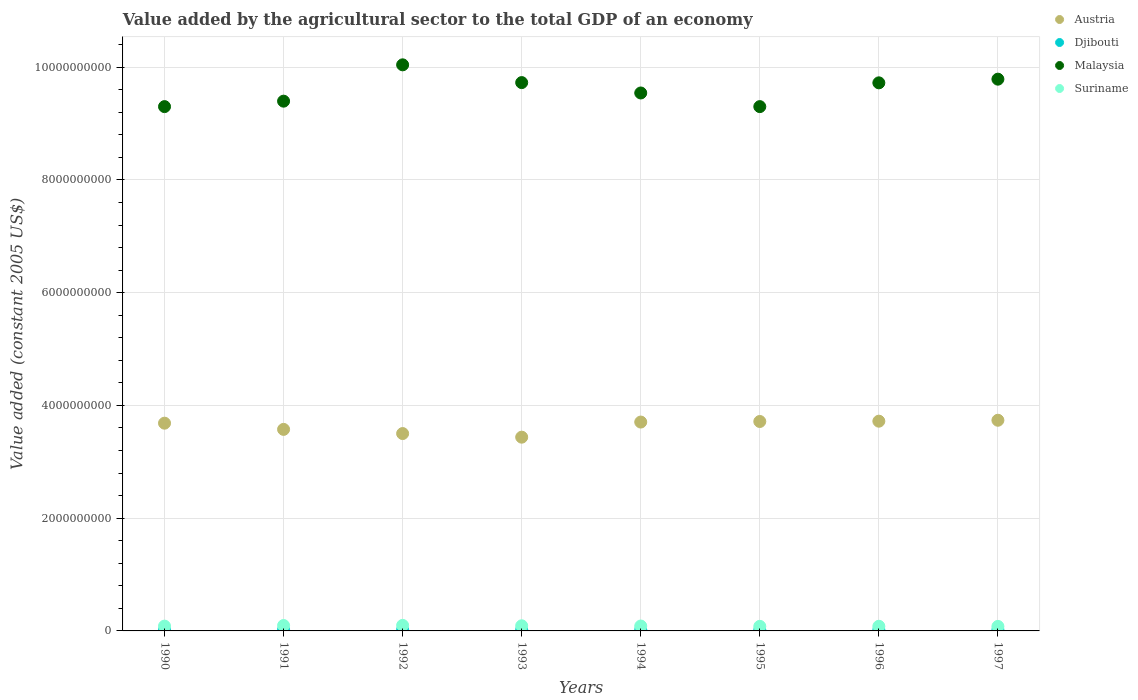What is the value added by the agricultural sector in Austria in 1997?
Provide a short and direct response. 3.74e+09. Across all years, what is the maximum value added by the agricultural sector in Suriname?
Keep it short and to the point. 9.80e+07. Across all years, what is the minimum value added by the agricultural sector in Suriname?
Your answer should be compact. 8.00e+07. What is the total value added by the agricultural sector in Djibouti in the graph?
Your response must be concise. 1.55e+08. What is the difference between the value added by the agricultural sector in Suriname in 1990 and that in 1993?
Provide a succinct answer. -5.70e+06. What is the difference between the value added by the agricultural sector in Austria in 1995 and the value added by the agricultural sector in Suriname in 1996?
Your answer should be very brief. 3.63e+09. What is the average value added by the agricultural sector in Malaysia per year?
Offer a very short reply. 9.60e+09. In the year 1991, what is the difference between the value added by the agricultural sector in Austria and value added by the agricultural sector in Suriname?
Your response must be concise. 3.48e+09. What is the ratio of the value added by the agricultural sector in Suriname in 1993 to that in 1996?
Ensure brevity in your answer.  1.1. Is the difference between the value added by the agricultural sector in Austria in 1994 and 1995 greater than the difference between the value added by the agricultural sector in Suriname in 1994 and 1995?
Your answer should be very brief. No. What is the difference between the highest and the second highest value added by the agricultural sector in Djibouti?
Keep it short and to the point. 2.11e+05. What is the difference between the highest and the lowest value added by the agricultural sector in Austria?
Ensure brevity in your answer.  3.00e+08. Is the value added by the agricultural sector in Suriname strictly greater than the value added by the agricultural sector in Djibouti over the years?
Provide a succinct answer. Yes. Is the value added by the agricultural sector in Malaysia strictly less than the value added by the agricultural sector in Djibouti over the years?
Your response must be concise. No. How many dotlines are there?
Your answer should be compact. 4. How many years are there in the graph?
Give a very brief answer. 8. Does the graph contain grids?
Provide a short and direct response. Yes. Where does the legend appear in the graph?
Your answer should be compact. Top right. What is the title of the graph?
Give a very brief answer. Value added by the agricultural sector to the total GDP of an economy. Does "Mauritania" appear as one of the legend labels in the graph?
Make the answer very short. No. What is the label or title of the X-axis?
Your answer should be very brief. Years. What is the label or title of the Y-axis?
Make the answer very short. Value added (constant 2005 US$). What is the Value added (constant 2005 US$) in Austria in 1990?
Provide a short and direct response. 3.69e+09. What is the Value added (constant 2005 US$) of Djibouti in 1990?
Your response must be concise. 1.96e+07. What is the Value added (constant 2005 US$) in Malaysia in 1990?
Provide a succinct answer. 9.30e+09. What is the Value added (constant 2005 US$) of Suriname in 1990?
Your answer should be very brief. 8.52e+07. What is the Value added (constant 2005 US$) in Austria in 1991?
Offer a very short reply. 3.58e+09. What is the Value added (constant 2005 US$) of Djibouti in 1991?
Give a very brief answer. 1.95e+07. What is the Value added (constant 2005 US$) in Malaysia in 1991?
Provide a short and direct response. 9.40e+09. What is the Value added (constant 2005 US$) in Suriname in 1991?
Offer a terse response. 9.58e+07. What is the Value added (constant 2005 US$) of Austria in 1992?
Give a very brief answer. 3.50e+09. What is the Value added (constant 2005 US$) of Djibouti in 1992?
Ensure brevity in your answer.  2.03e+07. What is the Value added (constant 2005 US$) in Malaysia in 1992?
Ensure brevity in your answer.  1.00e+1. What is the Value added (constant 2005 US$) of Suriname in 1992?
Your answer should be very brief. 9.80e+07. What is the Value added (constant 2005 US$) in Austria in 1993?
Make the answer very short. 3.44e+09. What is the Value added (constant 2005 US$) of Djibouti in 1993?
Provide a short and direct response. 2.05e+07. What is the Value added (constant 2005 US$) in Malaysia in 1993?
Your answer should be very brief. 9.73e+09. What is the Value added (constant 2005 US$) of Suriname in 1993?
Provide a succinct answer. 9.09e+07. What is the Value added (constant 2005 US$) in Austria in 1994?
Provide a short and direct response. 3.71e+09. What is the Value added (constant 2005 US$) in Djibouti in 1994?
Ensure brevity in your answer.  2.07e+07. What is the Value added (constant 2005 US$) in Malaysia in 1994?
Keep it short and to the point. 9.54e+09. What is the Value added (constant 2005 US$) in Suriname in 1994?
Offer a very short reply. 8.69e+07. What is the Value added (constant 2005 US$) of Austria in 1995?
Offer a very short reply. 3.72e+09. What is the Value added (constant 2005 US$) of Djibouti in 1995?
Your answer should be very brief. 1.77e+07. What is the Value added (constant 2005 US$) in Malaysia in 1995?
Your answer should be compact. 9.30e+09. What is the Value added (constant 2005 US$) of Suriname in 1995?
Keep it short and to the point. 8.12e+07. What is the Value added (constant 2005 US$) of Austria in 1996?
Your answer should be compact. 3.72e+09. What is the Value added (constant 2005 US$) of Djibouti in 1996?
Your answer should be very brief. 1.83e+07. What is the Value added (constant 2005 US$) of Malaysia in 1996?
Offer a very short reply. 9.72e+09. What is the Value added (constant 2005 US$) in Suriname in 1996?
Keep it short and to the point. 8.24e+07. What is the Value added (constant 2005 US$) of Austria in 1997?
Give a very brief answer. 3.74e+09. What is the Value added (constant 2005 US$) in Djibouti in 1997?
Provide a short and direct response. 1.83e+07. What is the Value added (constant 2005 US$) of Malaysia in 1997?
Provide a short and direct response. 9.79e+09. What is the Value added (constant 2005 US$) of Suriname in 1997?
Keep it short and to the point. 8.00e+07. Across all years, what is the maximum Value added (constant 2005 US$) in Austria?
Your response must be concise. 3.74e+09. Across all years, what is the maximum Value added (constant 2005 US$) in Djibouti?
Make the answer very short. 2.07e+07. Across all years, what is the maximum Value added (constant 2005 US$) of Malaysia?
Ensure brevity in your answer.  1.00e+1. Across all years, what is the maximum Value added (constant 2005 US$) in Suriname?
Provide a short and direct response. 9.80e+07. Across all years, what is the minimum Value added (constant 2005 US$) of Austria?
Your response must be concise. 3.44e+09. Across all years, what is the minimum Value added (constant 2005 US$) in Djibouti?
Provide a succinct answer. 1.77e+07. Across all years, what is the minimum Value added (constant 2005 US$) in Malaysia?
Your response must be concise. 9.30e+09. Across all years, what is the minimum Value added (constant 2005 US$) of Suriname?
Your response must be concise. 8.00e+07. What is the total Value added (constant 2005 US$) of Austria in the graph?
Make the answer very short. 2.91e+1. What is the total Value added (constant 2005 US$) of Djibouti in the graph?
Offer a terse response. 1.55e+08. What is the total Value added (constant 2005 US$) in Malaysia in the graph?
Offer a very short reply. 7.68e+1. What is the total Value added (constant 2005 US$) in Suriname in the graph?
Give a very brief answer. 7.00e+08. What is the difference between the Value added (constant 2005 US$) in Austria in 1990 and that in 1991?
Provide a short and direct response. 1.10e+08. What is the difference between the Value added (constant 2005 US$) of Djibouti in 1990 and that in 1991?
Your response must be concise. 3.64e+04. What is the difference between the Value added (constant 2005 US$) in Malaysia in 1990 and that in 1991?
Your answer should be very brief. -9.67e+07. What is the difference between the Value added (constant 2005 US$) in Suriname in 1990 and that in 1991?
Give a very brief answer. -1.06e+07. What is the difference between the Value added (constant 2005 US$) of Austria in 1990 and that in 1992?
Keep it short and to the point. 1.84e+08. What is the difference between the Value added (constant 2005 US$) of Djibouti in 1990 and that in 1992?
Ensure brevity in your answer.  -7.27e+05. What is the difference between the Value added (constant 2005 US$) of Malaysia in 1990 and that in 1992?
Give a very brief answer. -7.41e+08. What is the difference between the Value added (constant 2005 US$) of Suriname in 1990 and that in 1992?
Provide a succinct answer. -1.28e+07. What is the difference between the Value added (constant 2005 US$) of Austria in 1990 and that in 1993?
Your response must be concise. 2.48e+08. What is the difference between the Value added (constant 2005 US$) of Djibouti in 1990 and that in 1993?
Offer a very short reply. -9.41e+05. What is the difference between the Value added (constant 2005 US$) in Malaysia in 1990 and that in 1993?
Give a very brief answer. -4.26e+08. What is the difference between the Value added (constant 2005 US$) in Suriname in 1990 and that in 1993?
Keep it short and to the point. -5.70e+06. What is the difference between the Value added (constant 2005 US$) in Austria in 1990 and that in 1994?
Keep it short and to the point. -1.99e+07. What is the difference between the Value added (constant 2005 US$) of Djibouti in 1990 and that in 1994?
Offer a terse response. -1.15e+06. What is the difference between the Value added (constant 2005 US$) in Malaysia in 1990 and that in 1994?
Make the answer very short. -2.42e+08. What is the difference between the Value added (constant 2005 US$) in Suriname in 1990 and that in 1994?
Provide a short and direct response. -1.63e+06. What is the difference between the Value added (constant 2005 US$) in Austria in 1990 and that in 1995?
Provide a short and direct response. -2.99e+07. What is the difference between the Value added (constant 2005 US$) of Djibouti in 1990 and that in 1995?
Give a very brief answer. 1.84e+06. What is the difference between the Value added (constant 2005 US$) of Suriname in 1990 and that in 1995?
Your answer should be compact. 4.07e+06. What is the difference between the Value added (constant 2005 US$) of Austria in 1990 and that in 1996?
Provide a succinct answer. -3.54e+07. What is the difference between the Value added (constant 2005 US$) of Djibouti in 1990 and that in 1996?
Ensure brevity in your answer.  1.24e+06. What is the difference between the Value added (constant 2005 US$) of Malaysia in 1990 and that in 1996?
Provide a succinct answer. -4.22e+08. What is the difference between the Value added (constant 2005 US$) of Suriname in 1990 and that in 1996?
Your answer should be compact. 2.82e+06. What is the difference between the Value added (constant 2005 US$) of Austria in 1990 and that in 1997?
Provide a short and direct response. -5.19e+07. What is the difference between the Value added (constant 2005 US$) in Djibouti in 1990 and that in 1997?
Give a very brief answer. 1.31e+06. What is the difference between the Value added (constant 2005 US$) in Malaysia in 1990 and that in 1997?
Your answer should be very brief. -4.87e+08. What is the difference between the Value added (constant 2005 US$) in Suriname in 1990 and that in 1997?
Your answer should be compact. 5.27e+06. What is the difference between the Value added (constant 2005 US$) in Austria in 1991 and that in 1992?
Provide a succinct answer. 7.42e+07. What is the difference between the Value added (constant 2005 US$) of Djibouti in 1991 and that in 1992?
Make the answer very short. -7.63e+05. What is the difference between the Value added (constant 2005 US$) in Malaysia in 1991 and that in 1992?
Give a very brief answer. -6.45e+08. What is the difference between the Value added (constant 2005 US$) in Suriname in 1991 and that in 1992?
Provide a short and direct response. -2.17e+06. What is the difference between the Value added (constant 2005 US$) of Austria in 1991 and that in 1993?
Your answer should be compact. 1.38e+08. What is the difference between the Value added (constant 2005 US$) in Djibouti in 1991 and that in 1993?
Ensure brevity in your answer.  -9.78e+05. What is the difference between the Value added (constant 2005 US$) in Malaysia in 1991 and that in 1993?
Offer a terse response. -3.29e+08. What is the difference between the Value added (constant 2005 US$) in Suriname in 1991 and that in 1993?
Ensure brevity in your answer.  4.89e+06. What is the difference between the Value added (constant 2005 US$) of Austria in 1991 and that in 1994?
Keep it short and to the point. -1.30e+08. What is the difference between the Value added (constant 2005 US$) of Djibouti in 1991 and that in 1994?
Your response must be concise. -1.19e+06. What is the difference between the Value added (constant 2005 US$) in Malaysia in 1991 and that in 1994?
Provide a succinct answer. -1.45e+08. What is the difference between the Value added (constant 2005 US$) in Suriname in 1991 and that in 1994?
Make the answer very short. 8.96e+06. What is the difference between the Value added (constant 2005 US$) of Austria in 1991 and that in 1995?
Keep it short and to the point. -1.40e+08. What is the difference between the Value added (constant 2005 US$) in Djibouti in 1991 and that in 1995?
Your answer should be very brief. 1.80e+06. What is the difference between the Value added (constant 2005 US$) of Malaysia in 1991 and that in 1995?
Provide a succinct answer. 9.67e+07. What is the difference between the Value added (constant 2005 US$) of Suriname in 1991 and that in 1995?
Make the answer very short. 1.47e+07. What is the difference between the Value added (constant 2005 US$) in Austria in 1991 and that in 1996?
Your answer should be compact. -1.45e+08. What is the difference between the Value added (constant 2005 US$) of Djibouti in 1991 and that in 1996?
Ensure brevity in your answer.  1.21e+06. What is the difference between the Value added (constant 2005 US$) of Malaysia in 1991 and that in 1996?
Your response must be concise. -3.25e+08. What is the difference between the Value added (constant 2005 US$) in Suriname in 1991 and that in 1996?
Offer a terse response. 1.34e+07. What is the difference between the Value added (constant 2005 US$) of Austria in 1991 and that in 1997?
Make the answer very short. -1.62e+08. What is the difference between the Value added (constant 2005 US$) of Djibouti in 1991 and that in 1997?
Keep it short and to the point. 1.27e+06. What is the difference between the Value added (constant 2005 US$) in Malaysia in 1991 and that in 1997?
Give a very brief answer. -3.90e+08. What is the difference between the Value added (constant 2005 US$) in Suriname in 1991 and that in 1997?
Your response must be concise. 1.59e+07. What is the difference between the Value added (constant 2005 US$) in Austria in 1992 and that in 1993?
Your response must be concise. 6.41e+07. What is the difference between the Value added (constant 2005 US$) in Djibouti in 1992 and that in 1993?
Your answer should be very brief. -2.15e+05. What is the difference between the Value added (constant 2005 US$) of Malaysia in 1992 and that in 1993?
Your answer should be compact. 3.15e+08. What is the difference between the Value added (constant 2005 US$) of Suriname in 1992 and that in 1993?
Your answer should be very brief. 7.06e+06. What is the difference between the Value added (constant 2005 US$) of Austria in 1992 and that in 1994?
Your answer should be compact. -2.04e+08. What is the difference between the Value added (constant 2005 US$) in Djibouti in 1992 and that in 1994?
Your answer should be very brief. -4.26e+05. What is the difference between the Value added (constant 2005 US$) of Malaysia in 1992 and that in 1994?
Provide a short and direct response. 4.99e+08. What is the difference between the Value added (constant 2005 US$) of Suriname in 1992 and that in 1994?
Your response must be concise. 1.11e+07. What is the difference between the Value added (constant 2005 US$) of Austria in 1992 and that in 1995?
Offer a terse response. -2.14e+08. What is the difference between the Value added (constant 2005 US$) in Djibouti in 1992 and that in 1995?
Provide a short and direct response. 2.56e+06. What is the difference between the Value added (constant 2005 US$) of Malaysia in 1992 and that in 1995?
Provide a short and direct response. 7.41e+08. What is the difference between the Value added (constant 2005 US$) of Suriname in 1992 and that in 1995?
Your answer should be compact. 1.68e+07. What is the difference between the Value added (constant 2005 US$) in Austria in 1992 and that in 1996?
Your answer should be compact. -2.20e+08. What is the difference between the Value added (constant 2005 US$) in Djibouti in 1992 and that in 1996?
Your response must be concise. 1.97e+06. What is the difference between the Value added (constant 2005 US$) of Malaysia in 1992 and that in 1996?
Your answer should be compact. 3.20e+08. What is the difference between the Value added (constant 2005 US$) of Suriname in 1992 and that in 1996?
Keep it short and to the point. 1.56e+07. What is the difference between the Value added (constant 2005 US$) in Austria in 1992 and that in 1997?
Keep it short and to the point. -2.36e+08. What is the difference between the Value added (constant 2005 US$) of Djibouti in 1992 and that in 1997?
Your answer should be very brief. 2.03e+06. What is the difference between the Value added (constant 2005 US$) in Malaysia in 1992 and that in 1997?
Keep it short and to the point. 2.54e+08. What is the difference between the Value added (constant 2005 US$) in Suriname in 1992 and that in 1997?
Provide a short and direct response. 1.80e+07. What is the difference between the Value added (constant 2005 US$) in Austria in 1993 and that in 1994?
Ensure brevity in your answer.  -2.68e+08. What is the difference between the Value added (constant 2005 US$) in Djibouti in 1993 and that in 1994?
Provide a succinct answer. -2.11e+05. What is the difference between the Value added (constant 2005 US$) of Malaysia in 1993 and that in 1994?
Make the answer very short. 1.84e+08. What is the difference between the Value added (constant 2005 US$) in Suriname in 1993 and that in 1994?
Provide a succinct answer. 4.07e+06. What is the difference between the Value added (constant 2005 US$) of Austria in 1993 and that in 1995?
Your answer should be compact. -2.78e+08. What is the difference between the Value added (constant 2005 US$) in Djibouti in 1993 and that in 1995?
Ensure brevity in your answer.  2.78e+06. What is the difference between the Value added (constant 2005 US$) of Malaysia in 1993 and that in 1995?
Provide a succinct answer. 4.26e+08. What is the difference between the Value added (constant 2005 US$) in Suriname in 1993 and that in 1995?
Provide a succinct answer. 9.77e+06. What is the difference between the Value added (constant 2005 US$) in Austria in 1993 and that in 1996?
Your answer should be very brief. -2.84e+08. What is the difference between the Value added (constant 2005 US$) of Djibouti in 1993 and that in 1996?
Your response must be concise. 2.18e+06. What is the difference between the Value added (constant 2005 US$) in Malaysia in 1993 and that in 1996?
Keep it short and to the point. 4.35e+06. What is the difference between the Value added (constant 2005 US$) of Suriname in 1993 and that in 1996?
Make the answer very short. 8.52e+06. What is the difference between the Value added (constant 2005 US$) of Austria in 1993 and that in 1997?
Make the answer very short. -3.00e+08. What is the difference between the Value added (constant 2005 US$) in Djibouti in 1993 and that in 1997?
Make the answer very short. 2.25e+06. What is the difference between the Value added (constant 2005 US$) in Malaysia in 1993 and that in 1997?
Your response must be concise. -6.09e+07. What is the difference between the Value added (constant 2005 US$) of Suriname in 1993 and that in 1997?
Your answer should be compact. 1.10e+07. What is the difference between the Value added (constant 2005 US$) of Austria in 1994 and that in 1995?
Your response must be concise. -1.01e+07. What is the difference between the Value added (constant 2005 US$) in Djibouti in 1994 and that in 1995?
Make the answer very short. 2.99e+06. What is the difference between the Value added (constant 2005 US$) in Malaysia in 1994 and that in 1995?
Offer a terse response. 2.42e+08. What is the difference between the Value added (constant 2005 US$) of Suriname in 1994 and that in 1995?
Your answer should be very brief. 5.70e+06. What is the difference between the Value added (constant 2005 US$) in Austria in 1994 and that in 1996?
Your answer should be very brief. -1.56e+07. What is the difference between the Value added (constant 2005 US$) of Djibouti in 1994 and that in 1996?
Your answer should be compact. 2.40e+06. What is the difference between the Value added (constant 2005 US$) of Malaysia in 1994 and that in 1996?
Offer a very short reply. -1.80e+08. What is the difference between the Value added (constant 2005 US$) of Suriname in 1994 and that in 1996?
Your answer should be compact. 4.45e+06. What is the difference between the Value added (constant 2005 US$) in Austria in 1994 and that in 1997?
Offer a very short reply. -3.21e+07. What is the difference between the Value added (constant 2005 US$) in Djibouti in 1994 and that in 1997?
Give a very brief answer. 2.46e+06. What is the difference between the Value added (constant 2005 US$) in Malaysia in 1994 and that in 1997?
Your answer should be very brief. -2.45e+08. What is the difference between the Value added (constant 2005 US$) of Suriname in 1994 and that in 1997?
Provide a short and direct response. 6.90e+06. What is the difference between the Value added (constant 2005 US$) of Austria in 1995 and that in 1996?
Make the answer very short. -5.47e+06. What is the difference between the Value added (constant 2005 US$) of Djibouti in 1995 and that in 1996?
Provide a short and direct response. -5.95e+05. What is the difference between the Value added (constant 2005 US$) of Malaysia in 1995 and that in 1996?
Offer a terse response. -4.22e+08. What is the difference between the Value added (constant 2005 US$) of Suriname in 1995 and that in 1996?
Provide a short and direct response. -1.25e+06. What is the difference between the Value added (constant 2005 US$) of Austria in 1995 and that in 1997?
Provide a short and direct response. -2.20e+07. What is the difference between the Value added (constant 2005 US$) in Djibouti in 1995 and that in 1997?
Your response must be concise. -5.31e+05. What is the difference between the Value added (constant 2005 US$) of Malaysia in 1995 and that in 1997?
Make the answer very short. -4.87e+08. What is the difference between the Value added (constant 2005 US$) in Suriname in 1995 and that in 1997?
Give a very brief answer. 1.19e+06. What is the difference between the Value added (constant 2005 US$) in Austria in 1996 and that in 1997?
Offer a very short reply. -1.65e+07. What is the difference between the Value added (constant 2005 US$) in Djibouti in 1996 and that in 1997?
Make the answer very short. 6.39e+04. What is the difference between the Value added (constant 2005 US$) of Malaysia in 1996 and that in 1997?
Offer a terse response. -6.52e+07. What is the difference between the Value added (constant 2005 US$) in Suriname in 1996 and that in 1997?
Give a very brief answer. 2.44e+06. What is the difference between the Value added (constant 2005 US$) of Austria in 1990 and the Value added (constant 2005 US$) of Djibouti in 1991?
Your answer should be compact. 3.67e+09. What is the difference between the Value added (constant 2005 US$) in Austria in 1990 and the Value added (constant 2005 US$) in Malaysia in 1991?
Your answer should be compact. -5.71e+09. What is the difference between the Value added (constant 2005 US$) of Austria in 1990 and the Value added (constant 2005 US$) of Suriname in 1991?
Provide a succinct answer. 3.59e+09. What is the difference between the Value added (constant 2005 US$) in Djibouti in 1990 and the Value added (constant 2005 US$) in Malaysia in 1991?
Provide a short and direct response. -9.38e+09. What is the difference between the Value added (constant 2005 US$) in Djibouti in 1990 and the Value added (constant 2005 US$) in Suriname in 1991?
Keep it short and to the point. -7.62e+07. What is the difference between the Value added (constant 2005 US$) in Malaysia in 1990 and the Value added (constant 2005 US$) in Suriname in 1991?
Your answer should be very brief. 9.21e+09. What is the difference between the Value added (constant 2005 US$) in Austria in 1990 and the Value added (constant 2005 US$) in Djibouti in 1992?
Your answer should be very brief. 3.67e+09. What is the difference between the Value added (constant 2005 US$) in Austria in 1990 and the Value added (constant 2005 US$) in Malaysia in 1992?
Offer a terse response. -6.36e+09. What is the difference between the Value added (constant 2005 US$) of Austria in 1990 and the Value added (constant 2005 US$) of Suriname in 1992?
Provide a succinct answer. 3.59e+09. What is the difference between the Value added (constant 2005 US$) of Djibouti in 1990 and the Value added (constant 2005 US$) of Malaysia in 1992?
Offer a very short reply. -1.00e+1. What is the difference between the Value added (constant 2005 US$) in Djibouti in 1990 and the Value added (constant 2005 US$) in Suriname in 1992?
Provide a short and direct response. -7.84e+07. What is the difference between the Value added (constant 2005 US$) of Malaysia in 1990 and the Value added (constant 2005 US$) of Suriname in 1992?
Provide a short and direct response. 9.20e+09. What is the difference between the Value added (constant 2005 US$) in Austria in 1990 and the Value added (constant 2005 US$) in Djibouti in 1993?
Ensure brevity in your answer.  3.66e+09. What is the difference between the Value added (constant 2005 US$) in Austria in 1990 and the Value added (constant 2005 US$) in Malaysia in 1993?
Offer a very short reply. -6.04e+09. What is the difference between the Value added (constant 2005 US$) of Austria in 1990 and the Value added (constant 2005 US$) of Suriname in 1993?
Provide a succinct answer. 3.59e+09. What is the difference between the Value added (constant 2005 US$) in Djibouti in 1990 and the Value added (constant 2005 US$) in Malaysia in 1993?
Make the answer very short. -9.71e+09. What is the difference between the Value added (constant 2005 US$) of Djibouti in 1990 and the Value added (constant 2005 US$) of Suriname in 1993?
Provide a succinct answer. -7.14e+07. What is the difference between the Value added (constant 2005 US$) in Malaysia in 1990 and the Value added (constant 2005 US$) in Suriname in 1993?
Provide a succinct answer. 9.21e+09. What is the difference between the Value added (constant 2005 US$) in Austria in 1990 and the Value added (constant 2005 US$) in Djibouti in 1994?
Your answer should be very brief. 3.66e+09. What is the difference between the Value added (constant 2005 US$) in Austria in 1990 and the Value added (constant 2005 US$) in Malaysia in 1994?
Your answer should be very brief. -5.86e+09. What is the difference between the Value added (constant 2005 US$) in Austria in 1990 and the Value added (constant 2005 US$) in Suriname in 1994?
Make the answer very short. 3.60e+09. What is the difference between the Value added (constant 2005 US$) of Djibouti in 1990 and the Value added (constant 2005 US$) of Malaysia in 1994?
Offer a very short reply. -9.52e+09. What is the difference between the Value added (constant 2005 US$) of Djibouti in 1990 and the Value added (constant 2005 US$) of Suriname in 1994?
Provide a short and direct response. -6.73e+07. What is the difference between the Value added (constant 2005 US$) in Malaysia in 1990 and the Value added (constant 2005 US$) in Suriname in 1994?
Keep it short and to the point. 9.21e+09. What is the difference between the Value added (constant 2005 US$) of Austria in 1990 and the Value added (constant 2005 US$) of Djibouti in 1995?
Offer a terse response. 3.67e+09. What is the difference between the Value added (constant 2005 US$) in Austria in 1990 and the Value added (constant 2005 US$) in Malaysia in 1995?
Make the answer very short. -5.62e+09. What is the difference between the Value added (constant 2005 US$) of Austria in 1990 and the Value added (constant 2005 US$) of Suriname in 1995?
Offer a terse response. 3.60e+09. What is the difference between the Value added (constant 2005 US$) of Djibouti in 1990 and the Value added (constant 2005 US$) of Malaysia in 1995?
Ensure brevity in your answer.  -9.28e+09. What is the difference between the Value added (constant 2005 US$) in Djibouti in 1990 and the Value added (constant 2005 US$) in Suriname in 1995?
Provide a short and direct response. -6.16e+07. What is the difference between the Value added (constant 2005 US$) in Malaysia in 1990 and the Value added (constant 2005 US$) in Suriname in 1995?
Offer a terse response. 9.22e+09. What is the difference between the Value added (constant 2005 US$) of Austria in 1990 and the Value added (constant 2005 US$) of Djibouti in 1996?
Your response must be concise. 3.67e+09. What is the difference between the Value added (constant 2005 US$) in Austria in 1990 and the Value added (constant 2005 US$) in Malaysia in 1996?
Keep it short and to the point. -6.04e+09. What is the difference between the Value added (constant 2005 US$) in Austria in 1990 and the Value added (constant 2005 US$) in Suriname in 1996?
Your response must be concise. 3.60e+09. What is the difference between the Value added (constant 2005 US$) of Djibouti in 1990 and the Value added (constant 2005 US$) of Malaysia in 1996?
Your answer should be very brief. -9.70e+09. What is the difference between the Value added (constant 2005 US$) in Djibouti in 1990 and the Value added (constant 2005 US$) in Suriname in 1996?
Ensure brevity in your answer.  -6.28e+07. What is the difference between the Value added (constant 2005 US$) in Malaysia in 1990 and the Value added (constant 2005 US$) in Suriname in 1996?
Provide a short and direct response. 9.22e+09. What is the difference between the Value added (constant 2005 US$) in Austria in 1990 and the Value added (constant 2005 US$) in Djibouti in 1997?
Offer a terse response. 3.67e+09. What is the difference between the Value added (constant 2005 US$) of Austria in 1990 and the Value added (constant 2005 US$) of Malaysia in 1997?
Offer a terse response. -6.10e+09. What is the difference between the Value added (constant 2005 US$) of Austria in 1990 and the Value added (constant 2005 US$) of Suriname in 1997?
Keep it short and to the point. 3.61e+09. What is the difference between the Value added (constant 2005 US$) of Djibouti in 1990 and the Value added (constant 2005 US$) of Malaysia in 1997?
Provide a succinct answer. -9.77e+09. What is the difference between the Value added (constant 2005 US$) in Djibouti in 1990 and the Value added (constant 2005 US$) in Suriname in 1997?
Make the answer very short. -6.04e+07. What is the difference between the Value added (constant 2005 US$) of Malaysia in 1990 and the Value added (constant 2005 US$) of Suriname in 1997?
Make the answer very short. 9.22e+09. What is the difference between the Value added (constant 2005 US$) in Austria in 1991 and the Value added (constant 2005 US$) in Djibouti in 1992?
Offer a terse response. 3.55e+09. What is the difference between the Value added (constant 2005 US$) in Austria in 1991 and the Value added (constant 2005 US$) in Malaysia in 1992?
Keep it short and to the point. -6.47e+09. What is the difference between the Value added (constant 2005 US$) in Austria in 1991 and the Value added (constant 2005 US$) in Suriname in 1992?
Keep it short and to the point. 3.48e+09. What is the difference between the Value added (constant 2005 US$) of Djibouti in 1991 and the Value added (constant 2005 US$) of Malaysia in 1992?
Keep it short and to the point. -1.00e+1. What is the difference between the Value added (constant 2005 US$) of Djibouti in 1991 and the Value added (constant 2005 US$) of Suriname in 1992?
Your answer should be very brief. -7.84e+07. What is the difference between the Value added (constant 2005 US$) of Malaysia in 1991 and the Value added (constant 2005 US$) of Suriname in 1992?
Keep it short and to the point. 9.30e+09. What is the difference between the Value added (constant 2005 US$) in Austria in 1991 and the Value added (constant 2005 US$) in Djibouti in 1993?
Keep it short and to the point. 3.55e+09. What is the difference between the Value added (constant 2005 US$) in Austria in 1991 and the Value added (constant 2005 US$) in Malaysia in 1993?
Keep it short and to the point. -6.15e+09. What is the difference between the Value added (constant 2005 US$) in Austria in 1991 and the Value added (constant 2005 US$) in Suriname in 1993?
Offer a terse response. 3.48e+09. What is the difference between the Value added (constant 2005 US$) of Djibouti in 1991 and the Value added (constant 2005 US$) of Malaysia in 1993?
Provide a short and direct response. -9.71e+09. What is the difference between the Value added (constant 2005 US$) of Djibouti in 1991 and the Value added (constant 2005 US$) of Suriname in 1993?
Offer a very short reply. -7.14e+07. What is the difference between the Value added (constant 2005 US$) of Malaysia in 1991 and the Value added (constant 2005 US$) of Suriname in 1993?
Keep it short and to the point. 9.31e+09. What is the difference between the Value added (constant 2005 US$) of Austria in 1991 and the Value added (constant 2005 US$) of Djibouti in 1994?
Make the answer very short. 3.55e+09. What is the difference between the Value added (constant 2005 US$) in Austria in 1991 and the Value added (constant 2005 US$) in Malaysia in 1994?
Your answer should be compact. -5.97e+09. What is the difference between the Value added (constant 2005 US$) of Austria in 1991 and the Value added (constant 2005 US$) of Suriname in 1994?
Make the answer very short. 3.49e+09. What is the difference between the Value added (constant 2005 US$) of Djibouti in 1991 and the Value added (constant 2005 US$) of Malaysia in 1994?
Offer a very short reply. -9.52e+09. What is the difference between the Value added (constant 2005 US$) in Djibouti in 1991 and the Value added (constant 2005 US$) in Suriname in 1994?
Provide a succinct answer. -6.73e+07. What is the difference between the Value added (constant 2005 US$) in Malaysia in 1991 and the Value added (constant 2005 US$) in Suriname in 1994?
Your answer should be compact. 9.31e+09. What is the difference between the Value added (constant 2005 US$) of Austria in 1991 and the Value added (constant 2005 US$) of Djibouti in 1995?
Provide a succinct answer. 3.56e+09. What is the difference between the Value added (constant 2005 US$) of Austria in 1991 and the Value added (constant 2005 US$) of Malaysia in 1995?
Your response must be concise. -5.73e+09. What is the difference between the Value added (constant 2005 US$) of Austria in 1991 and the Value added (constant 2005 US$) of Suriname in 1995?
Ensure brevity in your answer.  3.49e+09. What is the difference between the Value added (constant 2005 US$) in Djibouti in 1991 and the Value added (constant 2005 US$) in Malaysia in 1995?
Your answer should be very brief. -9.28e+09. What is the difference between the Value added (constant 2005 US$) in Djibouti in 1991 and the Value added (constant 2005 US$) in Suriname in 1995?
Provide a succinct answer. -6.16e+07. What is the difference between the Value added (constant 2005 US$) in Malaysia in 1991 and the Value added (constant 2005 US$) in Suriname in 1995?
Provide a succinct answer. 9.32e+09. What is the difference between the Value added (constant 2005 US$) of Austria in 1991 and the Value added (constant 2005 US$) of Djibouti in 1996?
Make the answer very short. 3.56e+09. What is the difference between the Value added (constant 2005 US$) of Austria in 1991 and the Value added (constant 2005 US$) of Malaysia in 1996?
Offer a terse response. -6.15e+09. What is the difference between the Value added (constant 2005 US$) of Austria in 1991 and the Value added (constant 2005 US$) of Suriname in 1996?
Offer a very short reply. 3.49e+09. What is the difference between the Value added (constant 2005 US$) of Djibouti in 1991 and the Value added (constant 2005 US$) of Malaysia in 1996?
Make the answer very short. -9.70e+09. What is the difference between the Value added (constant 2005 US$) in Djibouti in 1991 and the Value added (constant 2005 US$) in Suriname in 1996?
Your answer should be compact. -6.29e+07. What is the difference between the Value added (constant 2005 US$) in Malaysia in 1991 and the Value added (constant 2005 US$) in Suriname in 1996?
Offer a very short reply. 9.32e+09. What is the difference between the Value added (constant 2005 US$) of Austria in 1991 and the Value added (constant 2005 US$) of Djibouti in 1997?
Your answer should be compact. 3.56e+09. What is the difference between the Value added (constant 2005 US$) of Austria in 1991 and the Value added (constant 2005 US$) of Malaysia in 1997?
Provide a short and direct response. -6.21e+09. What is the difference between the Value added (constant 2005 US$) of Austria in 1991 and the Value added (constant 2005 US$) of Suriname in 1997?
Offer a very short reply. 3.50e+09. What is the difference between the Value added (constant 2005 US$) in Djibouti in 1991 and the Value added (constant 2005 US$) in Malaysia in 1997?
Give a very brief answer. -9.77e+09. What is the difference between the Value added (constant 2005 US$) of Djibouti in 1991 and the Value added (constant 2005 US$) of Suriname in 1997?
Offer a very short reply. -6.04e+07. What is the difference between the Value added (constant 2005 US$) of Malaysia in 1991 and the Value added (constant 2005 US$) of Suriname in 1997?
Offer a very short reply. 9.32e+09. What is the difference between the Value added (constant 2005 US$) in Austria in 1992 and the Value added (constant 2005 US$) in Djibouti in 1993?
Your answer should be compact. 3.48e+09. What is the difference between the Value added (constant 2005 US$) in Austria in 1992 and the Value added (constant 2005 US$) in Malaysia in 1993?
Your answer should be very brief. -6.23e+09. What is the difference between the Value added (constant 2005 US$) in Austria in 1992 and the Value added (constant 2005 US$) in Suriname in 1993?
Keep it short and to the point. 3.41e+09. What is the difference between the Value added (constant 2005 US$) of Djibouti in 1992 and the Value added (constant 2005 US$) of Malaysia in 1993?
Offer a terse response. -9.71e+09. What is the difference between the Value added (constant 2005 US$) in Djibouti in 1992 and the Value added (constant 2005 US$) in Suriname in 1993?
Provide a short and direct response. -7.06e+07. What is the difference between the Value added (constant 2005 US$) of Malaysia in 1992 and the Value added (constant 2005 US$) of Suriname in 1993?
Ensure brevity in your answer.  9.95e+09. What is the difference between the Value added (constant 2005 US$) in Austria in 1992 and the Value added (constant 2005 US$) in Djibouti in 1994?
Your answer should be compact. 3.48e+09. What is the difference between the Value added (constant 2005 US$) of Austria in 1992 and the Value added (constant 2005 US$) of Malaysia in 1994?
Provide a short and direct response. -6.04e+09. What is the difference between the Value added (constant 2005 US$) in Austria in 1992 and the Value added (constant 2005 US$) in Suriname in 1994?
Make the answer very short. 3.41e+09. What is the difference between the Value added (constant 2005 US$) in Djibouti in 1992 and the Value added (constant 2005 US$) in Malaysia in 1994?
Provide a succinct answer. -9.52e+09. What is the difference between the Value added (constant 2005 US$) of Djibouti in 1992 and the Value added (constant 2005 US$) of Suriname in 1994?
Provide a short and direct response. -6.66e+07. What is the difference between the Value added (constant 2005 US$) of Malaysia in 1992 and the Value added (constant 2005 US$) of Suriname in 1994?
Your answer should be compact. 9.96e+09. What is the difference between the Value added (constant 2005 US$) of Austria in 1992 and the Value added (constant 2005 US$) of Djibouti in 1995?
Keep it short and to the point. 3.48e+09. What is the difference between the Value added (constant 2005 US$) in Austria in 1992 and the Value added (constant 2005 US$) in Malaysia in 1995?
Offer a terse response. -5.80e+09. What is the difference between the Value added (constant 2005 US$) in Austria in 1992 and the Value added (constant 2005 US$) in Suriname in 1995?
Keep it short and to the point. 3.42e+09. What is the difference between the Value added (constant 2005 US$) of Djibouti in 1992 and the Value added (constant 2005 US$) of Malaysia in 1995?
Give a very brief answer. -9.28e+09. What is the difference between the Value added (constant 2005 US$) of Djibouti in 1992 and the Value added (constant 2005 US$) of Suriname in 1995?
Your response must be concise. -6.09e+07. What is the difference between the Value added (constant 2005 US$) of Malaysia in 1992 and the Value added (constant 2005 US$) of Suriname in 1995?
Provide a short and direct response. 9.96e+09. What is the difference between the Value added (constant 2005 US$) of Austria in 1992 and the Value added (constant 2005 US$) of Djibouti in 1996?
Offer a terse response. 3.48e+09. What is the difference between the Value added (constant 2005 US$) of Austria in 1992 and the Value added (constant 2005 US$) of Malaysia in 1996?
Your response must be concise. -6.22e+09. What is the difference between the Value added (constant 2005 US$) of Austria in 1992 and the Value added (constant 2005 US$) of Suriname in 1996?
Provide a succinct answer. 3.42e+09. What is the difference between the Value added (constant 2005 US$) in Djibouti in 1992 and the Value added (constant 2005 US$) in Malaysia in 1996?
Make the answer very short. -9.70e+09. What is the difference between the Value added (constant 2005 US$) of Djibouti in 1992 and the Value added (constant 2005 US$) of Suriname in 1996?
Your answer should be compact. -6.21e+07. What is the difference between the Value added (constant 2005 US$) of Malaysia in 1992 and the Value added (constant 2005 US$) of Suriname in 1996?
Give a very brief answer. 9.96e+09. What is the difference between the Value added (constant 2005 US$) in Austria in 1992 and the Value added (constant 2005 US$) in Djibouti in 1997?
Your answer should be very brief. 3.48e+09. What is the difference between the Value added (constant 2005 US$) in Austria in 1992 and the Value added (constant 2005 US$) in Malaysia in 1997?
Offer a very short reply. -6.29e+09. What is the difference between the Value added (constant 2005 US$) in Austria in 1992 and the Value added (constant 2005 US$) in Suriname in 1997?
Provide a short and direct response. 3.42e+09. What is the difference between the Value added (constant 2005 US$) of Djibouti in 1992 and the Value added (constant 2005 US$) of Malaysia in 1997?
Provide a short and direct response. -9.77e+09. What is the difference between the Value added (constant 2005 US$) of Djibouti in 1992 and the Value added (constant 2005 US$) of Suriname in 1997?
Provide a succinct answer. -5.97e+07. What is the difference between the Value added (constant 2005 US$) in Malaysia in 1992 and the Value added (constant 2005 US$) in Suriname in 1997?
Give a very brief answer. 9.96e+09. What is the difference between the Value added (constant 2005 US$) in Austria in 1993 and the Value added (constant 2005 US$) in Djibouti in 1994?
Give a very brief answer. 3.42e+09. What is the difference between the Value added (constant 2005 US$) of Austria in 1993 and the Value added (constant 2005 US$) of Malaysia in 1994?
Your answer should be very brief. -6.11e+09. What is the difference between the Value added (constant 2005 US$) of Austria in 1993 and the Value added (constant 2005 US$) of Suriname in 1994?
Offer a very short reply. 3.35e+09. What is the difference between the Value added (constant 2005 US$) of Djibouti in 1993 and the Value added (constant 2005 US$) of Malaysia in 1994?
Offer a terse response. -9.52e+09. What is the difference between the Value added (constant 2005 US$) in Djibouti in 1993 and the Value added (constant 2005 US$) in Suriname in 1994?
Keep it short and to the point. -6.63e+07. What is the difference between the Value added (constant 2005 US$) in Malaysia in 1993 and the Value added (constant 2005 US$) in Suriname in 1994?
Provide a short and direct response. 9.64e+09. What is the difference between the Value added (constant 2005 US$) in Austria in 1993 and the Value added (constant 2005 US$) in Djibouti in 1995?
Your answer should be compact. 3.42e+09. What is the difference between the Value added (constant 2005 US$) in Austria in 1993 and the Value added (constant 2005 US$) in Malaysia in 1995?
Ensure brevity in your answer.  -5.86e+09. What is the difference between the Value added (constant 2005 US$) of Austria in 1993 and the Value added (constant 2005 US$) of Suriname in 1995?
Provide a short and direct response. 3.36e+09. What is the difference between the Value added (constant 2005 US$) of Djibouti in 1993 and the Value added (constant 2005 US$) of Malaysia in 1995?
Offer a terse response. -9.28e+09. What is the difference between the Value added (constant 2005 US$) of Djibouti in 1993 and the Value added (constant 2005 US$) of Suriname in 1995?
Your answer should be compact. -6.06e+07. What is the difference between the Value added (constant 2005 US$) of Malaysia in 1993 and the Value added (constant 2005 US$) of Suriname in 1995?
Make the answer very short. 9.65e+09. What is the difference between the Value added (constant 2005 US$) in Austria in 1993 and the Value added (constant 2005 US$) in Djibouti in 1996?
Offer a very short reply. 3.42e+09. What is the difference between the Value added (constant 2005 US$) of Austria in 1993 and the Value added (constant 2005 US$) of Malaysia in 1996?
Make the answer very short. -6.29e+09. What is the difference between the Value added (constant 2005 US$) in Austria in 1993 and the Value added (constant 2005 US$) in Suriname in 1996?
Give a very brief answer. 3.35e+09. What is the difference between the Value added (constant 2005 US$) in Djibouti in 1993 and the Value added (constant 2005 US$) in Malaysia in 1996?
Ensure brevity in your answer.  -9.70e+09. What is the difference between the Value added (constant 2005 US$) in Djibouti in 1993 and the Value added (constant 2005 US$) in Suriname in 1996?
Give a very brief answer. -6.19e+07. What is the difference between the Value added (constant 2005 US$) of Malaysia in 1993 and the Value added (constant 2005 US$) of Suriname in 1996?
Make the answer very short. 9.64e+09. What is the difference between the Value added (constant 2005 US$) in Austria in 1993 and the Value added (constant 2005 US$) in Djibouti in 1997?
Offer a very short reply. 3.42e+09. What is the difference between the Value added (constant 2005 US$) in Austria in 1993 and the Value added (constant 2005 US$) in Malaysia in 1997?
Offer a very short reply. -6.35e+09. What is the difference between the Value added (constant 2005 US$) in Austria in 1993 and the Value added (constant 2005 US$) in Suriname in 1997?
Your answer should be compact. 3.36e+09. What is the difference between the Value added (constant 2005 US$) in Djibouti in 1993 and the Value added (constant 2005 US$) in Malaysia in 1997?
Ensure brevity in your answer.  -9.77e+09. What is the difference between the Value added (constant 2005 US$) in Djibouti in 1993 and the Value added (constant 2005 US$) in Suriname in 1997?
Your answer should be very brief. -5.94e+07. What is the difference between the Value added (constant 2005 US$) of Malaysia in 1993 and the Value added (constant 2005 US$) of Suriname in 1997?
Keep it short and to the point. 9.65e+09. What is the difference between the Value added (constant 2005 US$) in Austria in 1994 and the Value added (constant 2005 US$) in Djibouti in 1995?
Keep it short and to the point. 3.69e+09. What is the difference between the Value added (constant 2005 US$) of Austria in 1994 and the Value added (constant 2005 US$) of Malaysia in 1995?
Provide a succinct answer. -5.60e+09. What is the difference between the Value added (constant 2005 US$) in Austria in 1994 and the Value added (constant 2005 US$) in Suriname in 1995?
Give a very brief answer. 3.62e+09. What is the difference between the Value added (constant 2005 US$) of Djibouti in 1994 and the Value added (constant 2005 US$) of Malaysia in 1995?
Keep it short and to the point. -9.28e+09. What is the difference between the Value added (constant 2005 US$) in Djibouti in 1994 and the Value added (constant 2005 US$) in Suriname in 1995?
Ensure brevity in your answer.  -6.04e+07. What is the difference between the Value added (constant 2005 US$) in Malaysia in 1994 and the Value added (constant 2005 US$) in Suriname in 1995?
Make the answer very short. 9.46e+09. What is the difference between the Value added (constant 2005 US$) in Austria in 1994 and the Value added (constant 2005 US$) in Djibouti in 1996?
Provide a short and direct response. 3.69e+09. What is the difference between the Value added (constant 2005 US$) of Austria in 1994 and the Value added (constant 2005 US$) of Malaysia in 1996?
Ensure brevity in your answer.  -6.02e+09. What is the difference between the Value added (constant 2005 US$) in Austria in 1994 and the Value added (constant 2005 US$) in Suriname in 1996?
Provide a short and direct response. 3.62e+09. What is the difference between the Value added (constant 2005 US$) of Djibouti in 1994 and the Value added (constant 2005 US$) of Malaysia in 1996?
Give a very brief answer. -9.70e+09. What is the difference between the Value added (constant 2005 US$) of Djibouti in 1994 and the Value added (constant 2005 US$) of Suriname in 1996?
Provide a succinct answer. -6.17e+07. What is the difference between the Value added (constant 2005 US$) of Malaysia in 1994 and the Value added (constant 2005 US$) of Suriname in 1996?
Offer a very short reply. 9.46e+09. What is the difference between the Value added (constant 2005 US$) of Austria in 1994 and the Value added (constant 2005 US$) of Djibouti in 1997?
Offer a terse response. 3.69e+09. What is the difference between the Value added (constant 2005 US$) of Austria in 1994 and the Value added (constant 2005 US$) of Malaysia in 1997?
Offer a terse response. -6.08e+09. What is the difference between the Value added (constant 2005 US$) of Austria in 1994 and the Value added (constant 2005 US$) of Suriname in 1997?
Provide a succinct answer. 3.63e+09. What is the difference between the Value added (constant 2005 US$) of Djibouti in 1994 and the Value added (constant 2005 US$) of Malaysia in 1997?
Keep it short and to the point. -9.77e+09. What is the difference between the Value added (constant 2005 US$) of Djibouti in 1994 and the Value added (constant 2005 US$) of Suriname in 1997?
Offer a very short reply. -5.92e+07. What is the difference between the Value added (constant 2005 US$) of Malaysia in 1994 and the Value added (constant 2005 US$) of Suriname in 1997?
Keep it short and to the point. 9.46e+09. What is the difference between the Value added (constant 2005 US$) of Austria in 1995 and the Value added (constant 2005 US$) of Djibouti in 1996?
Your answer should be compact. 3.70e+09. What is the difference between the Value added (constant 2005 US$) in Austria in 1995 and the Value added (constant 2005 US$) in Malaysia in 1996?
Your answer should be very brief. -6.01e+09. What is the difference between the Value added (constant 2005 US$) in Austria in 1995 and the Value added (constant 2005 US$) in Suriname in 1996?
Provide a succinct answer. 3.63e+09. What is the difference between the Value added (constant 2005 US$) in Djibouti in 1995 and the Value added (constant 2005 US$) in Malaysia in 1996?
Offer a terse response. -9.71e+09. What is the difference between the Value added (constant 2005 US$) of Djibouti in 1995 and the Value added (constant 2005 US$) of Suriname in 1996?
Provide a short and direct response. -6.47e+07. What is the difference between the Value added (constant 2005 US$) in Malaysia in 1995 and the Value added (constant 2005 US$) in Suriname in 1996?
Your answer should be compact. 9.22e+09. What is the difference between the Value added (constant 2005 US$) in Austria in 1995 and the Value added (constant 2005 US$) in Djibouti in 1997?
Your response must be concise. 3.70e+09. What is the difference between the Value added (constant 2005 US$) of Austria in 1995 and the Value added (constant 2005 US$) of Malaysia in 1997?
Give a very brief answer. -6.07e+09. What is the difference between the Value added (constant 2005 US$) in Austria in 1995 and the Value added (constant 2005 US$) in Suriname in 1997?
Offer a terse response. 3.64e+09. What is the difference between the Value added (constant 2005 US$) of Djibouti in 1995 and the Value added (constant 2005 US$) of Malaysia in 1997?
Your answer should be very brief. -9.77e+09. What is the difference between the Value added (constant 2005 US$) in Djibouti in 1995 and the Value added (constant 2005 US$) in Suriname in 1997?
Your answer should be compact. -6.22e+07. What is the difference between the Value added (constant 2005 US$) in Malaysia in 1995 and the Value added (constant 2005 US$) in Suriname in 1997?
Make the answer very short. 9.22e+09. What is the difference between the Value added (constant 2005 US$) of Austria in 1996 and the Value added (constant 2005 US$) of Djibouti in 1997?
Give a very brief answer. 3.70e+09. What is the difference between the Value added (constant 2005 US$) in Austria in 1996 and the Value added (constant 2005 US$) in Malaysia in 1997?
Provide a succinct answer. -6.07e+09. What is the difference between the Value added (constant 2005 US$) of Austria in 1996 and the Value added (constant 2005 US$) of Suriname in 1997?
Provide a succinct answer. 3.64e+09. What is the difference between the Value added (constant 2005 US$) in Djibouti in 1996 and the Value added (constant 2005 US$) in Malaysia in 1997?
Offer a very short reply. -9.77e+09. What is the difference between the Value added (constant 2005 US$) of Djibouti in 1996 and the Value added (constant 2005 US$) of Suriname in 1997?
Provide a succinct answer. -6.16e+07. What is the difference between the Value added (constant 2005 US$) of Malaysia in 1996 and the Value added (constant 2005 US$) of Suriname in 1997?
Provide a succinct answer. 9.64e+09. What is the average Value added (constant 2005 US$) of Austria per year?
Your response must be concise. 3.63e+09. What is the average Value added (constant 2005 US$) of Djibouti per year?
Offer a very short reply. 1.94e+07. What is the average Value added (constant 2005 US$) in Malaysia per year?
Your answer should be very brief. 9.60e+09. What is the average Value added (constant 2005 US$) of Suriname per year?
Offer a terse response. 8.76e+07. In the year 1990, what is the difference between the Value added (constant 2005 US$) of Austria and Value added (constant 2005 US$) of Djibouti?
Ensure brevity in your answer.  3.67e+09. In the year 1990, what is the difference between the Value added (constant 2005 US$) in Austria and Value added (constant 2005 US$) in Malaysia?
Give a very brief answer. -5.62e+09. In the year 1990, what is the difference between the Value added (constant 2005 US$) in Austria and Value added (constant 2005 US$) in Suriname?
Give a very brief answer. 3.60e+09. In the year 1990, what is the difference between the Value added (constant 2005 US$) in Djibouti and Value added (constant 2005 US$) in Malaysia?
Offer a terse response. -9.28e+09. In the year 1990, what is the difference between the Value added (constant 2005 US$) of Djibouti and Value added (constant 2005 US$) of Suriname?
Your answer should be very brief. -6.57e+07. In the year 1990, what is the difference between the Value added (constant 2005 US$) of Malaysia and Value added (constant 2005 US$) of Suriname?
Provide a succinct answer. 9.22e+09. In the year 1991, what is the difference between the Value added (constant 2005 US$) in Austria and Value added (constant 2005 US$) in Djibouti?
Ensure brevity in your answer.  3.56e+09. In the year 1991, what is the difference between the Value added (constant 2005 US$) of Austria and Value added (constant 2005 US$) of Malaysia?
Offer a terse response. -5.82e+09. In the year 1991, what is the difference between the Value added (constant 2005 US$) in Austria and Value added (constant 2005 US$) in Suriname?
Your answer should be very brief. 3.48e+09. In the year 1991, what is the difference between the Value added (constant 2005 US$) in Djibouti and Value added (constant 2005 US$) in Malaysia?
Keep it short and to the point. -9.38e+09. In the year 1991, what is the difference between the Value added (constant 2005 US$) in Djibouti and Value added (constant 2005 US$) in Suriname?
Make the answer very short. -7.63e+07. In the year 1991, what is the difference between the Value added (constant 2005 US$) of Malaysia and Value added (constant 2005 US$) of Suriname?
Give a very brief answer. 9.30e+09. In the year 1992, what is the difference between the Value added (constant 2005 US$) of Austria and Value added (constant 2005 US$) of Djibouti?
Offer a very short reply. 3.48e+09. In the year 1992, what is the difference between the Value added (constant 2005 US$) in Austria and Value added (constant 2005 US$) in Malaysia?
Your response must be concise. -6.54e+09. In the year 1992, what is the difference between the Value added (constant 2005 US$) of Austria and Value added (constant 2005 US$) of Suriname?
Offer a very short reply. 3.40e+09. In the year 1992, what is the difference between the Value added (constant 2005 US$) in Djibouti and Value added (constant 2005 US$) in Malaysia?
Your response must be concise. -1.00e+1. In the year 1992, what is the difference between the Value added (constant 2005 US$) of Djibouti and Value added (constant 2005 US$) of Suriname?
Give a very brief answer. -7.77e+07. In the year 1992, what is the difference between the Value added (constant 2005 US$) of Malaysia and Value added (constant 2005 US$) of Suriname?
Make the answer very short. 9.94e+09. In the year 1993, what is the difference between the Value added (constant 2005 US$) in Austria and Value added (constant 2005 US$) in Djibouti?
Ensure brevity in your answer.  3.42e+09. In the year 1993, what is the difference between the Value added (constant 2005 US$) in Austria and Value added (constant 2005 US$) in Malaysia?
Your answer should be very brief. -6.29e+09. In the year 1993, what is the difference between the Value added (constant 2005 US$) of Austria and Value added (constant 2005 US$) of Suriname?
Provide a short and direct response. 3.35e+09. In the year 1993, what is the difference between the Value added (constant 2005 US$) of Djibouti and Value added (constant 2005 US$) of Malaysia?
Give a very brief answer. -9.71e+09. In the year 1993, what is the difference between the Value added (constant 2005 US$) in Djibouti and Value added (constant 2005 US$) in Suriname?
Provide a short and direct response. -7.04e+07. In the year 1993, what is the difference between the Value added (constant 2005 US$) in Malaysia and Value added (constant 2005 US$) in Suriname?
Provide a short and direct response. 9.64e+09. In the year 1994, what is the difference between the Value added (constant 2005 US$) in Austria and Value added (constant 2005 US$) in Djibouti?
Your answer should be very brief. 3.68e+09. In the year 1994, what is the difference between the Value added (constant 2005 US$) of Austria and Value added (constant 2005 US$) of Malaysia?
Offer a terse response. -5.84e+09. In the year 1994, what is the difference between the Value added (constant 2005 US$) of Austria and Value added (constant 2005 US$) of Suriname?
Provide a succinct answer. 3.62e+09. In the year 1994, what is the difference between the Value added (constant 2005 US$) of Djibouti and Value added (constant 2005 US$) of Malaysia?
Your answer should be compact. -9.52e+09. In the year 1994, what is the difference between the Value added (constant 2005 US$) of Djibouti and Value added (constant 2005 US$) of Suriname?
Provide a succinct answer. -6.61e+07. In the year 1994, what is the difference between the Value added (constant 2005 US$) of Malaysia and Value added (constant 2005 US$) of Suriname?
Give a very brief answer. 9.46e+09. In the year 1995, what is the difference between the Value added (constant 2005 US$) of Austria and Value added (constant 2005 US$) of Djibouti?
Your answer should be very brief. 3.70e+09. In the year 1995, what is the difference between the Value added (constant 2005 US$) of Austria and Value added (constant 2005 US$) of Malaysia?
Provide a short and direct response. -5.59e+09. In the year 1995, what is the difference between the Value added (constant 2005 US$) of Austria and Value added (constant 2005 US$) of Suriname?
Offer a very short reply. 3.63e+09. In the year 1995, what is the difference between the Value added (constant 2005 US$) of Djibouti and Value added (constant 2005 US$) of Malaysia?
Offer a very short reply. -9.28e+09. In the year 1995, what is the difference between the Value added (constant 2005 US$) of Djibouti and Value added (constant 2005 US$) of Suriname?
Make the answer very short. -6.34e+07. In the year 1995, what is the difference between the Value added (constant 2005 US$) in Malaysia and Value added (constant 2005 US$) in Suriname?
Your answer should be very brief. 9.22e+09. In the year 1996, what is the difference between the Value added (constant 2005 US$) in Austria and Value added (constant 2005 US$) in Djibouti?
Your answer should be very brief. 3.70e+09. In the year 1996, what is the difference between the Value added (constant 2005 US$) of Austria and Value added (constant 2005 US$) of Malaysia?
Your answer should be very brief. -6.00e+09. In the year 1996, what is the difference between the Value added (constant 2005 US$) of Austria and Value added (constant 2005 US$) of Suriname?
Your answer should be compact. 3.64e+09. In the year 1996, what is the difference between the Value added (constant 2005 US$) of Djibouti and Value added (constant 2005 US$) of Malaysia?
Your response must be concise. -9.70e+09. In the year 1996, what is the difference between the Value added (constant 2005 US$) of Djibouti and Value added (constant 2005 US$) of Suriname?
Offer a very short reply. -6.41e+07. In the year 1996, what is the difference between the Value added (constant 2005 US$) of Malaysia and Value added (constant 2005 US$) of Suriname?
Make the answer very short. 9.64e+09. In the year 1997, what is the difference between the Value added (constant 2005 US$) of Austria and Value added (constant 2005 US$) of Djibouti?
Ensure brevity in your answer.  3.72e+09. In the year 1997, what is the difference between the Value added (constant 2005 US$) in Austria and Value added (constant 2005 US$) in Malaysia?
Give a very brief answer. -6.05e+09. In the year 1997, what is the difference between the Value added (constant 2005 US$) of Austria and Value added (constant 2005 US$) of Suriname?
Provide a short and direct response. 3.66e+09. In the year 1997, what is the difference between the Value added (constant 2005 US$) of Djibouti and Value added (constant 2005 US$) of Malaysia?
Provide a short and direct response. -9.77e+09. In the year 1997, what is the difference between the Value added (constant 2005 US$) of Djibouti and Value added (constant 2005 US$) of Suriname?
Offer a very short reply. -6.17e+07. In the year 1997, what is the difference between the Value added (constant 2005 US$) of Malaysia and Value added (constant 2005 US$) of Suriname?
Provide a short and direct response. 9.71e+09. What is the ratio of the Value added (constant 2005 US$) of Austria in 1990 to that in 1991?
Provide a short and direct response. 1.03. What is the ratio of the Value added (constant 2005 US$) of Djibouti in 1990 to that in 1991?
Ensure brevity in your answer.  1. What is the ratio of the Value added (constant 2005 US$) in Malaysia in 1990 to that in 1991?
Offer a very short reply. 0.99. What is the ratio of the Value added (constant 2005 US$) in Suriname in 1990 to that in 1991?
Keep it short and to the point. 0.89. What is the ratio of the Value added (constant 2005 US$) in Austria in 1990 to that in 1992?
Offer a very short reply. 1.05. What is the ratio of the Value added (constant 2005 US$) of Djibouti in 1990 to that in 1992?
Provide a succinct answer. 0.96. What is the ratio of the Value added (constant 2005 US$) in Malaysia in 1990 to that in 1992?
Provide a succinct answer. 0.93. What is the ratio of the Value added (constant 2005 US$) in Suriname in 1990 to that in 1992?
Provide a succinct answer. 0.87. What is the ratio of the Value added (constant 2005 US$) in Austria in 1990 to that in 1993?
Give a very brief answer. 1.07. What is the ratio of the Value added (constant 2005 US$) of Djibouti in 1990 to that in 1993?
Provide a succinct answer. 0.95. What is the ratio of the Value added (constant 2005 US$) of Malaysia in 1990 to that in 1993?
Your answer should be compact. 0.96. What is the ratio of the Value added (constant 2005 US$) of Suriname in 1990 to that in 1993?
Keep it short and to the point. 0.94. What is the ratio of the Value added (constant 2005 US$) in Austria in 1990 to that in 1994?
Your answer should be compact. 0.99. What is the ratio of the Value added (constant 2005 US$) of Djibouti in 1990 to that in 1994?
Offer a very short reply. 0.94. What is the ratio of the Value added (constant 2005 US$) of Malaysia in 1990 to that in 1994?
Offer a very short reply. 0.97. What is the ratio of the Value added (constant 2005 US$) of Suriname in 1990 to that in 1994?
Give a very brief answer. 0.98. What is the ratio of the Value added (constant 2005 US$) of Austria in 1990 to that in 1995?
Your answer should be compact. 0.99. What is the ratio of the Value added (constant 2005 US$) of Djibouti in 1990 to that in 1995?
Make the answer very short. 1.1. What is the ratio of the Value added (constant 2005 US$) in Malaysia in 1990 to that in 1995?
Offer a very short reply. 1. What is the ratio of the Value added (constant 2005 US$) of Suriname in 1990 to that in 1995?
Your response must be concise. 1.05. What is the ratio of the Value added (constant 2005 US$) of Djibouti in 1990 to that in 1996?
Provide a short and direct response. 1.07. What is the ratio of the Value added (constant 2005 US$) in Malaysia in 1990 to that in 1996?
Ensure brevity in your answer.  0.96. What is the ratio of the Value added (constant 2005 US$) of Suriname in 1990 to that in 1996?
Your answer should be compact. 1.03. What is the ratio of the Value added (constant 2005 US$) of Austria in 1990 to that in 1997?
Give a very brief answer. 0.99. What is the ratio of the Value added (constant 2005 US$) of Djibouti in 1990 to that in 1997?
Offer a terse response. 1.07. What is the ratio of the Value added (constant 2005 US$) of Malaysia in 1990 to that in 1997?
Your answer should be very brief. 0.95. What is the ratio of the Value added (constant 2005 US$) of Suriname in 1990 to that in 1997?
Make the answer very short. 1.07. What is the ratio of the Value added (constant 2005 US$) in Austria in 1991 to that in 1992?
Keep it short and to the point. 1.02. What is the ratio of the Value added (constant 2005 US$) of Djibouti in 1991 to that in 1992?
Provide a short and direct response. 0.96. What is the ratio of the Value added (constant 2005 US$) of Malaysia in 1991 to that in 1992?
Your answer should be very brief. 0.94. What is the ratio of the Value added (constant 2005 US$) in Suriname in 1991 to that in 1992?
Offer a very short reply. 0.98. What is the ratio of the Value added (constant 2005 US$) of Austria in 1991 to that in 1993?
Provide a succinct answer. 1.04. What is the ratio of the Value added (constant 2005 US$) of Malaysia in 1991 to that in 1993?
Your answer should be compact. 0.97. What is the ratio of the Value added (constant 2005 US$) in Suriname in 1991 to that in 1993?
Your answer should be very brief. 1.05. What is the ratio of the Value added (constant 2005 US$) of Austria in 1991 to that in 1994?
Provide a short and direct response. 0.96. What is the ratio of the Value added (constant 2005 US$) of Djibouti in 1991 to that in 1994?
Your response must be concise. 0.94. What is the ratio of the Value added (constant 2005 US$) of Malaysia in 1991 to that in 1994?
Make the answer very short. 0.98. What is the ratio of the Value added (constant 2005 US$) in Suriname in 1991 to that in 1994?
Provide a succinct answer. 1.1. What is the ratio of the Value added (constant 2005 US$) of Austria in 1991 to that in 1995?
Offer a very short reply. 0.96. What is the ratio of the Value added (constant 2005 US$) in Djibouti in 1991 to that in 1995?
Provide a succinct answer. 1.1. What is the ratio of the Value added (constant 2005 US$) of Malaysia in 1991 to that in 1995?
Keep it short and to the point. 1.01. What is the ratio of the Value added (constant 2005 US$) of Suriname in 1991 to that in 1995?
Your response must be concise. 1.18. What is the ratio of the Value added (constant 2005 US$) of Austria in 1991 to that in 1996?
Offer a terse response. 0.96. What is the ratio of the Value added (constant 2005 US$) of Djibouti in 1991 to that in 1996?
Give a very brief answer. 1.07. What is the ratio of the Value added (constant 2005 US$) of Malaysia in 1991 to that in 1996?
Give a very brief answer. 0.97. What is the ratio of the Value added (constant 2005 US$) of Suriname in 1991 to that in 1996?
Your answer should be very brief. 1.16. What is the ratio of the Value added (constant 2005 US$) in Austria in 1991 to that in 1997?
Offer a very short reply. 0.96. What is the ratio of the Value added (constant 2005 US$) in Djibouti in 1991 to that in 1997?
Offer a very short reply. 1.07. What is the ratio of the Value added (constant 2005 US$) of Malaysia in 1991 to that in 1997?
Provide a succinct answer. 0.96. What is the ratio of the Value added (constant 2005 US$) in Suriname in 1991 to that in 1997?
Your answer should be very brief. 1.2. What is the ratio of the Value added (constant 2005 US$) in Austria in 1992 to that in 1993?
Your answer should be very brief. 1.02. What is the ratio of the Value added (constant 2005 US$) of Djibouti in 1992 to that in 1993?
Offer a terse response. 0.99. What is the ratio of the Value added (constant 2005 US$) of Malaysia in 1992 to that in 1993?
Your answer should be compact. 1.03. What is the ratio of the Value added (constant 2005 US$) in Suriname in 1992 to that in 1993?
Your answer should be very brief. 1.08. What is the ratio of the Value added (constant 2005 US$) in Austria in 1992 to that in 1994?
Your answer should be very brief. 0.94. What is the ratio of the Value added (constant 2005 US$) in Djibouti in 1992 to that in 1994?
Offer a terse response. 0.98. What is the ratio of the Value added (constant 2005 US$) of Malaysia in 1992 to that in 1994?
Your answer should be compact. 1.05. What is the ratio of the Value added (constant 2005 US$) in Suriname in 1992 to that in 1994?
Your answer should be compact. 1.13. What is the ratio of the Value added (constant 2005 US$) of Austria in 1992 to that in 1995?
Give a very brief answer. 0.94. What is the ratio of the Value added (constant 2005 US$) in Djibouti in 1992 to that in 1995?
Make the answer very short. 1.14. What is the ratio of the Value added (constant 2005 US$) in Malaysia in 1992 to that in 1995?
Make the answer very short. 1.08. What is the ratio of the Value added (constant 2005 US$) of Suriname in 1992 to that in 1995?
Provide a succinct answer. 1.21. What is the ratio of the Value added (constant 2005 US$) of Austria in 1992 to that in 1996?
Provide a succinct answer. 0.94. What is the ratio of the Value added (constant 2005 US$) in Djibouti in 1992 to that in 1996?
Offer a very short reply. 1.11. What is the ratio of the Value added (constant 2005 US$) in Malaysia in 1992 to that in 1996?
Ensure brevity in your answer.  1.03. What is the ratio of the Value added (constant 2005 US$) in Suriname in 1992 to that in 1996?
Provide a succinct answer. 1.19. What is the ratio of the Value added (constant 2005 US$) in Austria in 1992 to that in 1997?
Keep it short and to the point. 0.94. What is the ratio of the Value added (constant 2005 US$) of Djibouti in 1992 to that in 1997?
Your response must be concise. 1.11. What is the ratio of the Value added (constant 2005 US$) of Malaysia in 1992 to that in 1997?
Offer a very short reply. 1.03. What is the ratio of the Value added (constant 2005 US$) in Suriname in 1992 to that in 1997?
Offer a terse response. 1.23. What is the ratio of the Value added (constant 2005 US$) in Austria in 1993 to that in 1994?
Make the answer very short. 0.93. What is the ratio of the Value added (constant 2005 US$) of Djibouti in 1993 to that in 1994?
Provide a succinct answer. 0.99. What is the ratio of the Value added (constant 2005 US$) in Malaysia in 1993 to that in 1994?
Provide a succinct answer. 1.02. What is the ratio of the Value added (constant 2005 US$) of Suriname in 1993 to that in 1994?
Make the answer very short. 1.05. What is the ratio of the Value added (constant 2005 US$) of Austria in 1993 to that in 1995?
Give a very brief answer. 0.93. What is the ratio of the Value added (constant 2005 US$) of Djibouti in 1993 to that in 1995?
Give a very brief answer. 1.16. What is the ratio of the Value added (constant 2005 US$) in Malaysia in 1993 to that in 1995?
Make the answer very short. 1.05. What is the ratio of the Value added (constant 2005 US$) of Suriname in 1993 to that in 1995?
Your answer should be compact. 1.12. What is the ratio of the Value added (constant 2005 US$) in Austria in 1993 to that in 1996?
Make the answer very short. 0.92. What is the ratio of the Value added (constant 2005 US$) of Djibouti in 1993 to that in 1996?
Provide a succinct answer. 1.12. What is the ratio of the Value added (constant 2005 US$) of Malaysia in 1993 to that in 1996?
Your answer should be compact. 1. What is the ratio of the Value added (constant 2005 US$) of Suriname in 1993 to that in 1996?
Provide a short and direct response. 1.1. What is the ratio of the Value added (constant 2005 US$) in Austria in 1993 to that in 1997?
Ensure brevity in your answer.  0.92. What is the ratio of the Value added (constant 2005 US$) in Djibouti in 1993 to that in 1997?
Provide a short and direct response. 1.12. What is the ratio of the Value added (constant 2005 US$) in Suriname in 1993 to that in 1997?
Offer a very short reply. 1.14. What is the ratio of the Value added (constant 2005 US$) in Austria in 1994 to that in 1995?
Give a very brief answer. 1. What is the ratio of the Value added (constant 2005 US$) of Djibouti in 1994 to that in 1995?
Your response must be concise. 1.17. What is the ratio of the Value added (constant 2005 US$) in Malaysia in 1994 to that in 1995?
Keep it short and to the point. 1.03. What is the ratio of the Value added (constant 2005 US$) in Suriname in 1994 to that in 1995?
Your answer should be very brief. 1.07. What is the ratio of the Value added (constant 2005 US$) of Austria in 1994 to that in 1996?
Your response must be concise. 1. What is the ratio of the Value added (constant 2005 US$) in Djibouti in 1994 to that in 1996?
Provide a short and direct response. 1.13. What is the ratio of the Value added (constant 2005 US$) in Malaysia in 1994 to that in 1996?
Offer a very short reply. 0.98. What is the ratio of the Value added (constant 2005 US$) in Suriname in 1994 to that in 1996?
Offer a very short reply. 1.05. What is the ratio of the Value added (constant 2005 US$) in Austria in 1994 to that in 1997?
Give a very brief answer. 0.99. What is the ratio of the Value added (constant 2005 US$) in Djibouti in 1994 to that in 1997?
Provide a succinct answer. 1.13. What is the ratio of the Value added (constant 2005 US$) in Suriname in 1994 to that in 1997?
Ensure brevity in your answer.  1.09. What is the ratio of the Value added (constant 2005 US$) of Austria in 1995 to that in 1996?
Your answer should be compact. 1. What is the ratio of the Value added (constant 2005 US$) in Djibouti in 1995 to that in 1996?
Provide a short and direct response. 0.97. What is the ratio of the Value added (constant 2005 US$) of Malaysia in 1995 to that in 1996?
Your answer should be compact. 0.96. What is the ratio of the Value added (constant 2005 US$) of Austria in 1995 to that in 1997?
Provide a short and direct response. 0.99. What is the ratio of the Value added (constant 2005 US$) of Djibouti in 1995 to that in 1997?
Offer a very short reply. 0.97. What is the ratio of the Value added (constant 2005 US$) in Malaysia in 1995 to that in 1997?
Provide a short and direct response. 0.95. What is the ratio of the Value added (constant 2005 US$) in Suriname in 1995 to that in 1997?
Keep it short and to the point. 1.01. What is the ratio of the Value added (constant 2005 US$) of Suriname in 1996 to that in 1997?
Your answer should be very brief. 1.03. What is the difference between the highest and the second highest Value added (constant 2005 US$) of Austria?
Give a very brief answer. 1.65e+07. What is the difference between the highest and the second highest Value added (constant 2005 US$) in Djibouti?
Provide a short and direct response. 2.11e+05. What is the difference between the highest and the second highest Value added (constant 2005 US$) in Malaysia?
Offer a terse response. 2.54e+08. What is the difference between the highest and the second highest Value added (constant 2005 US$) of Suriname?
Your response must be concise. 2.17e+06. What is the difference between the highest and the lowest Value added (constant 2005 US$) in Austria?
Your answer should be very brief. 3.00e+08. What is the difference between the highest and the lowest Value added (constant 2005 US$) of Djibouti?
Provide a succinct answer. 2.99e+06. What is the difference between the highest and the lowest Value added (constant 2005 US$) of Malaysia?
Offer a very short reply. 7.41e+08. What is the difference between the highest and the lowest Value added (constant 2005 US$) in Suriname?
Provide a short and direct response. 1.80e+07. 